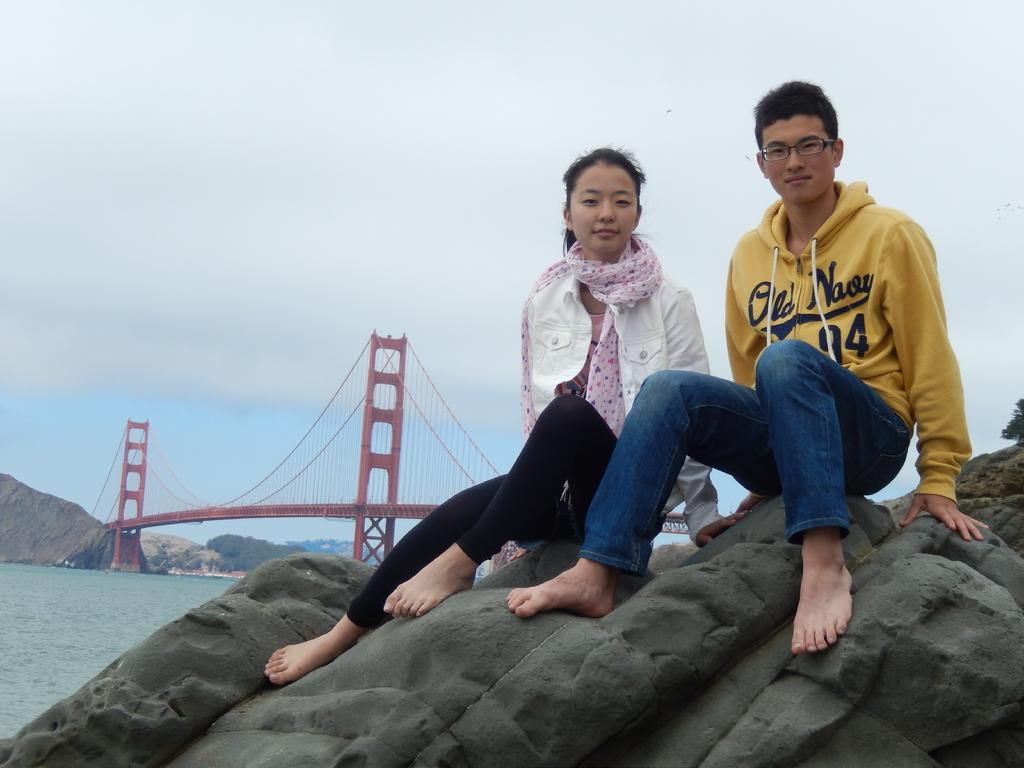What are the couple doing in the image? The couple is sitting on the rocks in the image. What structure can be seen behind the couple? There is a bridge behind the couple. What is flowing beneath the bridge? There is a river beneath the bridge. What can be seen in the distance behind the couple and the bridge? There are mountains in the background. What is visible above the mountains and the bridge? The sky is visible in the background. How many pages does the road have in the image? There is no road present in the image, so the concept of pages does not apply. 